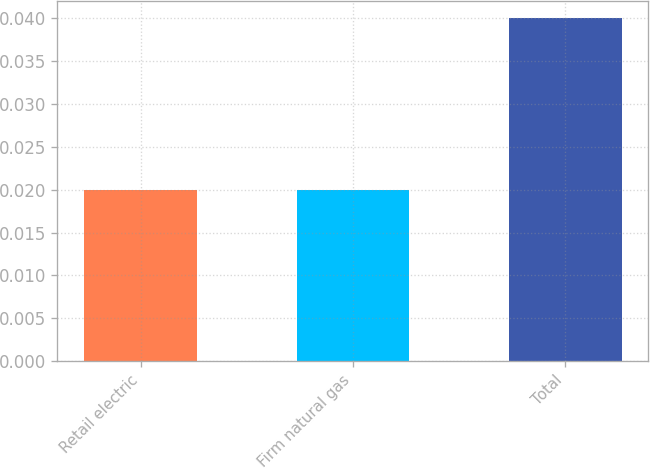Convert chart. <chart><loc_0><loc_0><loc_500><loc_500><bar_chart><fcel>Retail electric<fcel>Firm natural gas<fcel>Total<nl><fcel>0.02<fcel>0.02<fcel>0.04<nl></chart> 